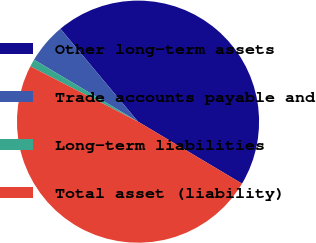Convert chart to OTSL. <chart><loc_0><loc_0><loc_500><loc_500><pie_chart><fcel>Other long-term assets<fcel>Trade accounts payable and<fcel>Long-term liabilities<fcel>Total asset (liability)<nl><fcel>44.63%<fcel>5.37%<fcel>1.0%<fcel>49.0%<nl></chart> 